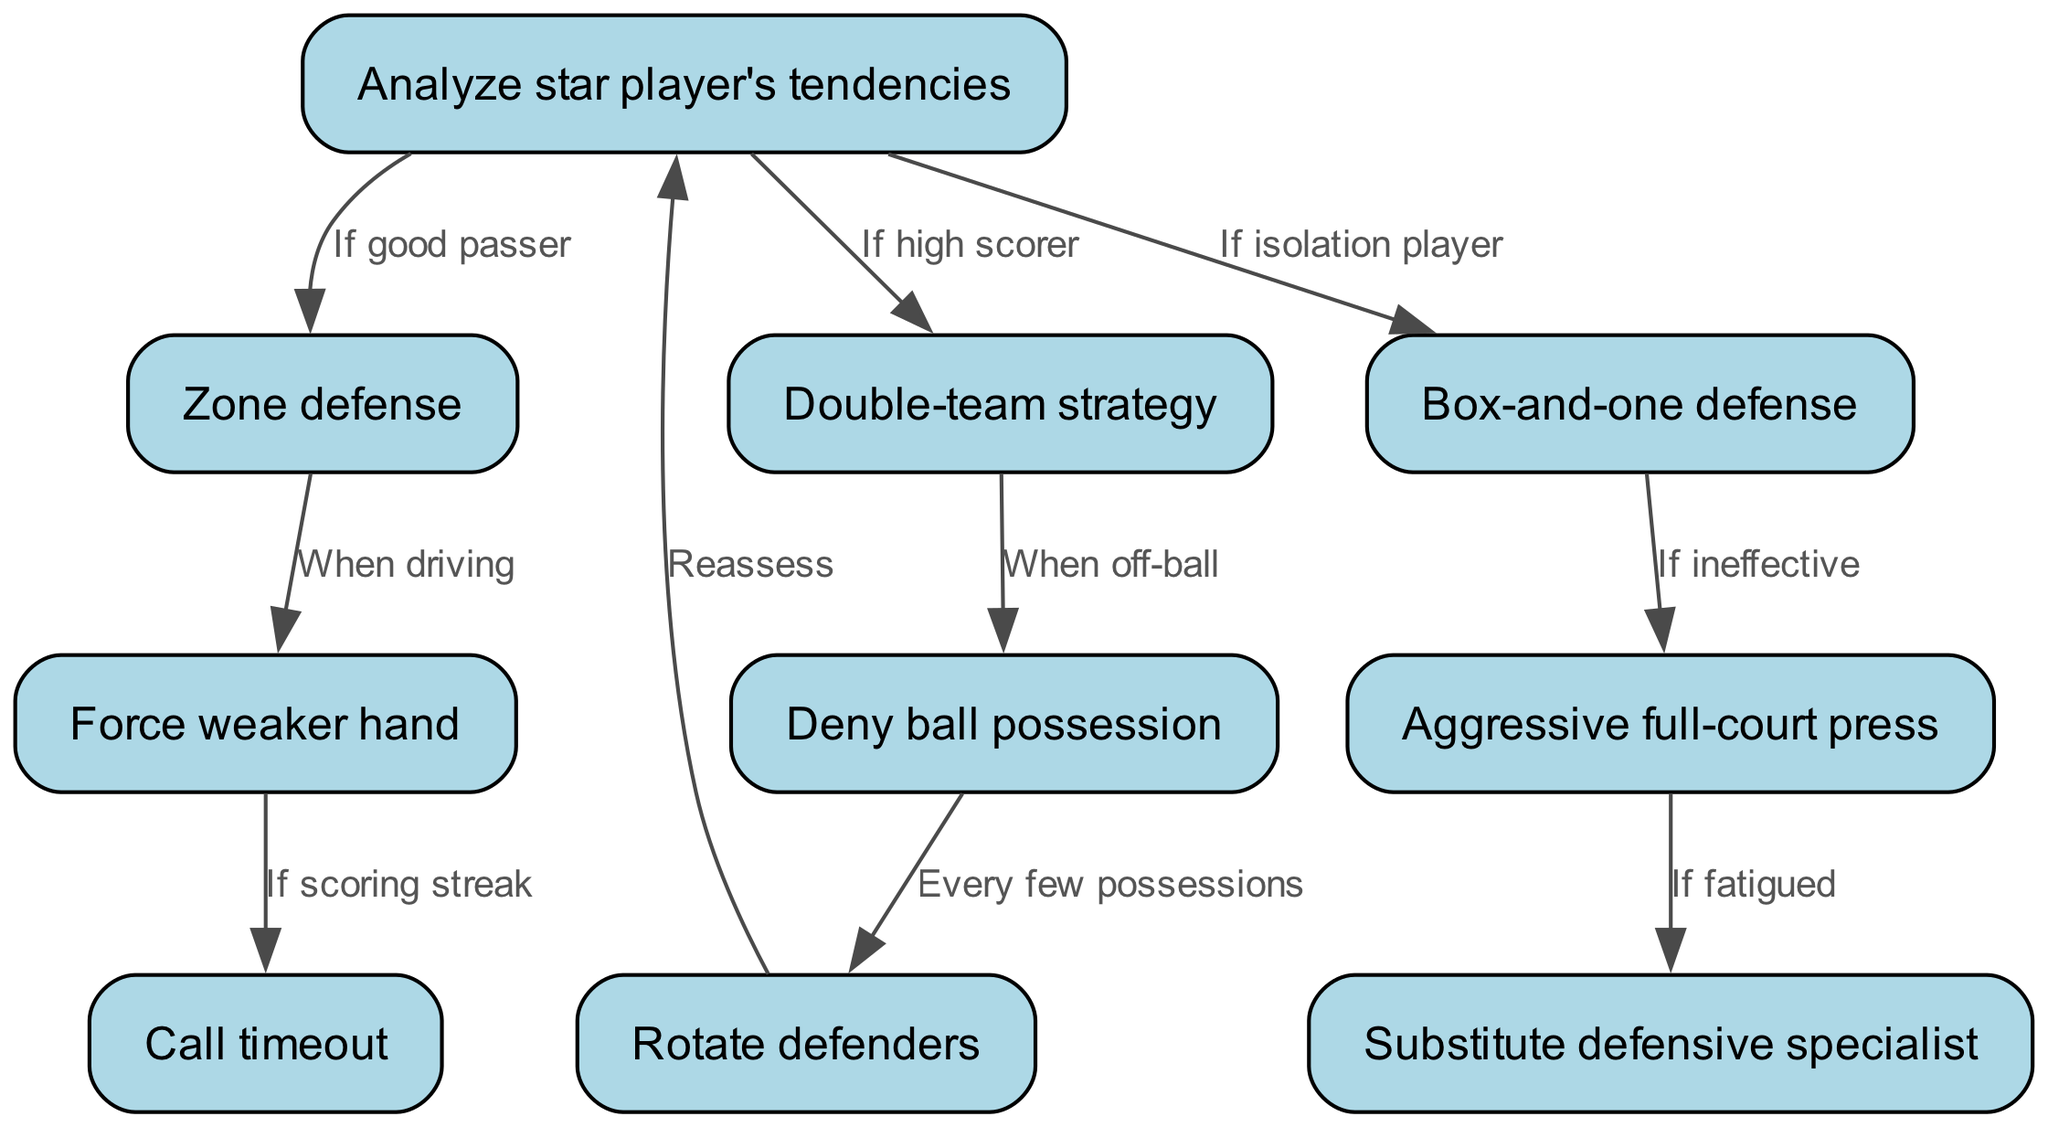What is the first step in the strategy? The first step mentioned in the diagram is to "Analyze star player's tendencies." This node is at the top of the flowchart and serves as the starting point for the defensive strategy.
Answer: Analyze star player's tendencies How many nodes are in this diagram? The diagram contains a total of 10 nodes listed, which include various defensive strategies and tactics. Each of these nodes represents a different aspect of containing the opposing team's star player.
Answer: 10 What does the "Box-and-one defense" lead to if it is ineffective? According to the diagram, if the "Box-and-one defense" is ineffective, it leads to the "Aggressive full-court press." This indicates a shift in strategy to further apply pressure defensively.
Answer: Aggressive full-court press What happens when you "Deny ball possession"? When you "Deny ball possession," the next step is to "Rotate defenders." This means that the defenders will change positions to maintain pressure and coverage on the star player.
Answer: Rotate defenders Which node is reached when the star player is a good passer? If the star player is identified as a good passer in the initial analysis, the strategy directs to the "Zone defense." This shows a specific adjustment in defensive tactics based on the player's abilities.
Answer: Zone defense What action is taken if the team is facing a scoring streak? If the team faces a scoring streak, the flowchart indicates that you should "Call timeout." This action is taken in response to regain composure and re-strategize defensively.
Answer: Call timeout What is the last defensive action to reassess the situation? The last action in the flowchart after "Rotate defenders" is to "Analyze star player's tendencies" again. This allows for continuous evaluation and adjustment of the defensive strategy.
Answer: Analyze star player's tendencies How would defenders adjust if they are fatigued while implementing a full-court press? If defenders are fatigued while executing the "Aggressive full-court press," the next action would be to "Substitute defensive specialist" to maintain defensive effectiveness and energy levels on the court.
Answer: Substitute defensive specialist What does "Force weaker hand" lead to if there is a scoring streak? If "Force weaker hand" results in a scoring streak, it leads to "Call timeout" which highlights the importance of addressing immediate challenges during the game through tactical pauses.
Answer: Call timeout 